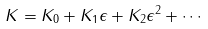<formula> <loc_0><loc_0><loc_500><loc_500>K = K _ { 0 } + K _ { 1 } \epsilon + K _ { 2 } \epsilon ^ { 2 } + \cdots</formula> 